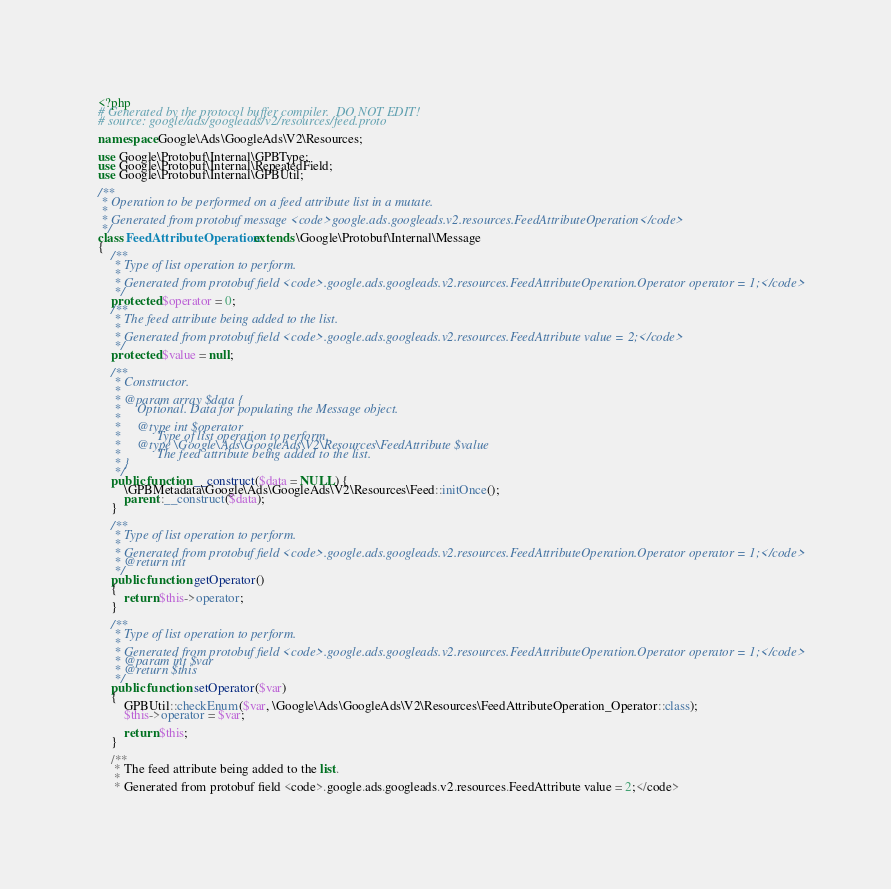Convert code to text. <code><loc_0><loc_0><loc_500><loc_500><_PHP_><?php
# Generated by the protocol buffer compiler.  DO NOT EDIT!
# source: google/ads/googleads/v2/resources/feed.proto

namespace Google\Ads\GoogleAds\V2\Resources;

use Google\Protobuf\Internal\GPBType;
use Google\Protobuf\Internal\RepeatedField;
use Google\Protobuf\Internal\GPBUtil;

/**
 * Operation to be performed on a feed attribute list in a mutate.
 *
 * Generated from protobuf message <code>google.ads.googleads.v2.resources.FeedAttributeOperation</code>
 */
class FeedAttributeOperation extends \Google\Protobuf\Internal\Message
{
    /**
     * Type of list operation to perform.
     *
     * Generated from protobuf field <code>.google.ads.googleads.v2.resources.FeedAttributeOperation.Operator operator = 1;</code>
     */
    protected $operator = 0;
    /**
     * The feed attribute being added to the list.
     *
     * Generated from protobuf field <code>.google.ads.googleads.v2.resources.FeedAttribute value = 2;</code>
     */
    protected $value = null;

    /**
     * Constructor.
     *
     * @param array $data {
     *     Optional. Data for populating the Message object.
     *
     *     @type int $operator
     *           Type of list operation to perform.
     *     @type \Google\Ads\GoogleAds\V2\Resources\FeedAttribute $value
     *           The feed attribute being added to the list.
     * }
     */
    public function __construct($data = NULL) {
        \GPBMetadata\Google\Ads\GoogleAds\V2\Resources\Feed::initOnce();
        parent::__construct($data);
    }

    /**
     * Type of list operation to perform.
     *
     * Generated from protobuf field <code>.google.ads.googleads.v2.resources.FeedAttributeOperation.Operator operator = 1;</code>
     * @return int
     */
    public function getOperator()
    {
        return $this->operator;
    }

    /**
     * Type of list operation to perform.
     *
     * Generated from protobuf field <code>.google.ads.googleads.v2.resources.FeedAttributeOperation.Operator operator = 1;</code>
     * @param int $var
     * @return $this
     */
    public function setOperator($var)
    {
        GPBUtil::checkEnum($var, \Google\Ads\GoogleAds\V2\Resources\FeedAttributeOperation_Operator::class);
        $this->operator = $var;

        return $this;
    }

    /**
     * The feed attribute being added to the list.
     *
     * Generated from protobuf field <code>.google.ads.googleads.v2.resources.FeedAttribute value = 2;</code></code> 